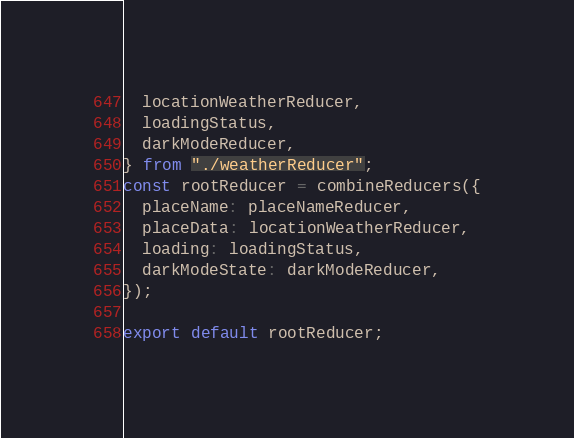<code> <loc_0><loc_0><loc_500><loc_500><_JavaScript_>  locationWeatherReducer,
  loadingStatus,
  darkModeReducer,
} from "./weatherReducer";
const rootReducer = combineReducers({
  placeName: placeNameReducer,
  placeData: locationWeatherReducer,
  loading: loadingStatus,
  darkModeState: darkModeReducer,
});

export default rootReducer;
</code> 